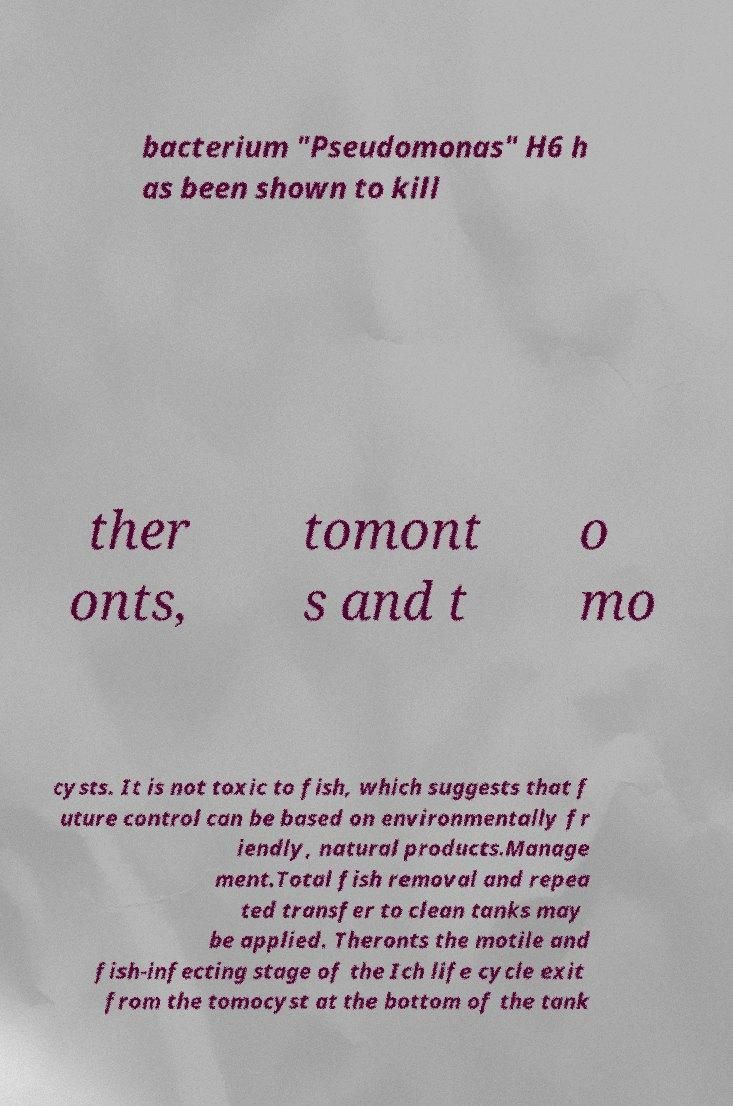There's text embedded in this image that I need extracted. Can you transcribe it verbatim? bacterium "Pseudomonas" H6 h as been shown to kill ther onts, tomont s and t o mo cysts. It is not toxic to fish, which suggests that f uture control can be based on environmentally fr iendly, natural products.Manage ment.Total fish removal and repea ted transfer to clean tanks may be applied. Theronts the motile and fish-infecting stage of the Ich life cycle exit from the tomocyst at the bottom of the tank 